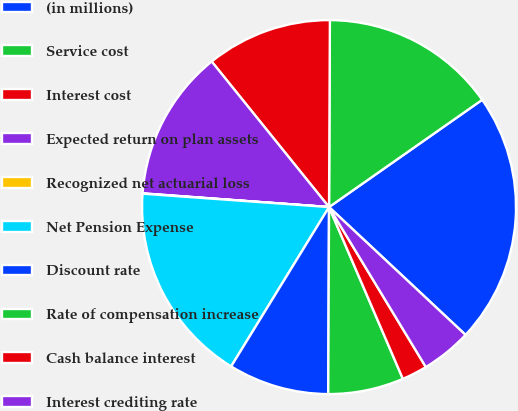Convert chart to OTSL. <chart><loc_0><loc_0><loc_500><loc_500><pie_chart><fcel>(in millions)<fcel>Service cost<fcel>Interest cost<fcel>Expected return on plan assets<fcel>Recognized net actuarial loss<fcel>Net Pension Expense<fcel>Discount rate<fcel>Rate of compensation increase<fcel>Cash balance interest<fcel>Interest crediting rate<nl><fcel>21.7%<fcel>15.2%<fcel>10.87%<fcel>13.03%<fcel>0.03%<fcel>17.37%<fcel>8.7%<fcel>6.53%<fcel>2.2%<fcel>4.36%<nl></chart> 